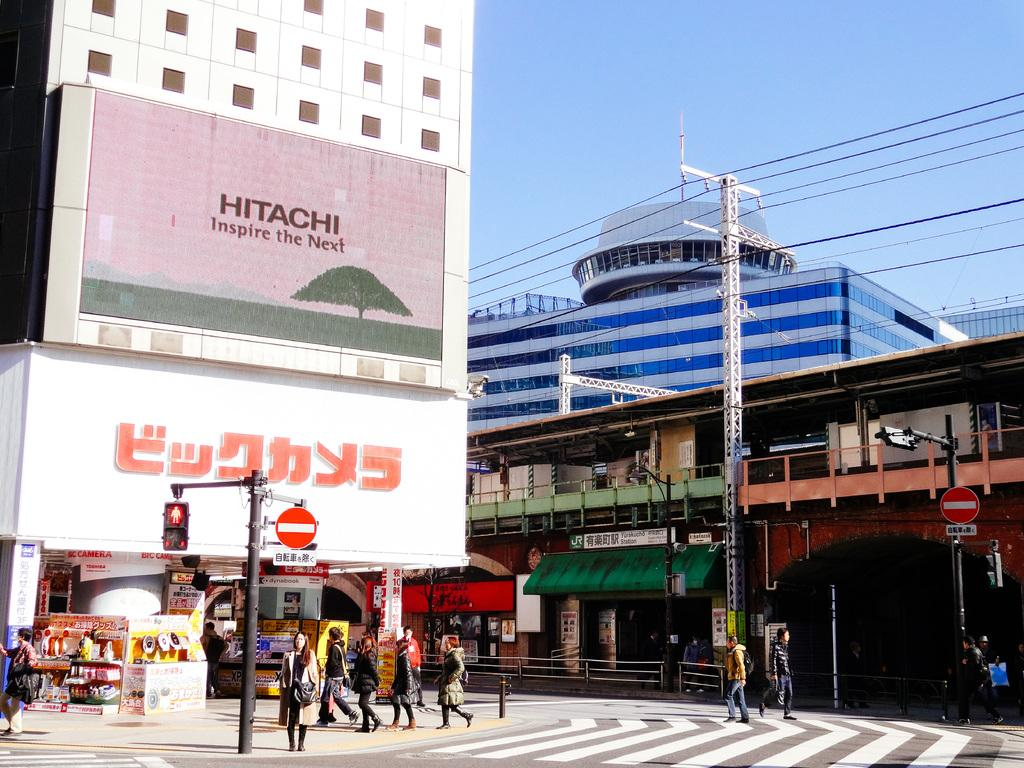What can be seen on the ground in the image? There are people on the ground in the image. What structures are present in the image? There are poles, boards, and buildings in the image. Can you describe any objects in the image? There are some objects in the image. What is visible in the background of the image? The sky is visible in the background of the image. Is there a bedroom visible in the image? There is no bedroom present in the image. Does the existence of the objects in the image prove the existence of a plane? The presence of objects in the image does not prove the existence of a plane, as there is no mention of a plane in the provided facts. 